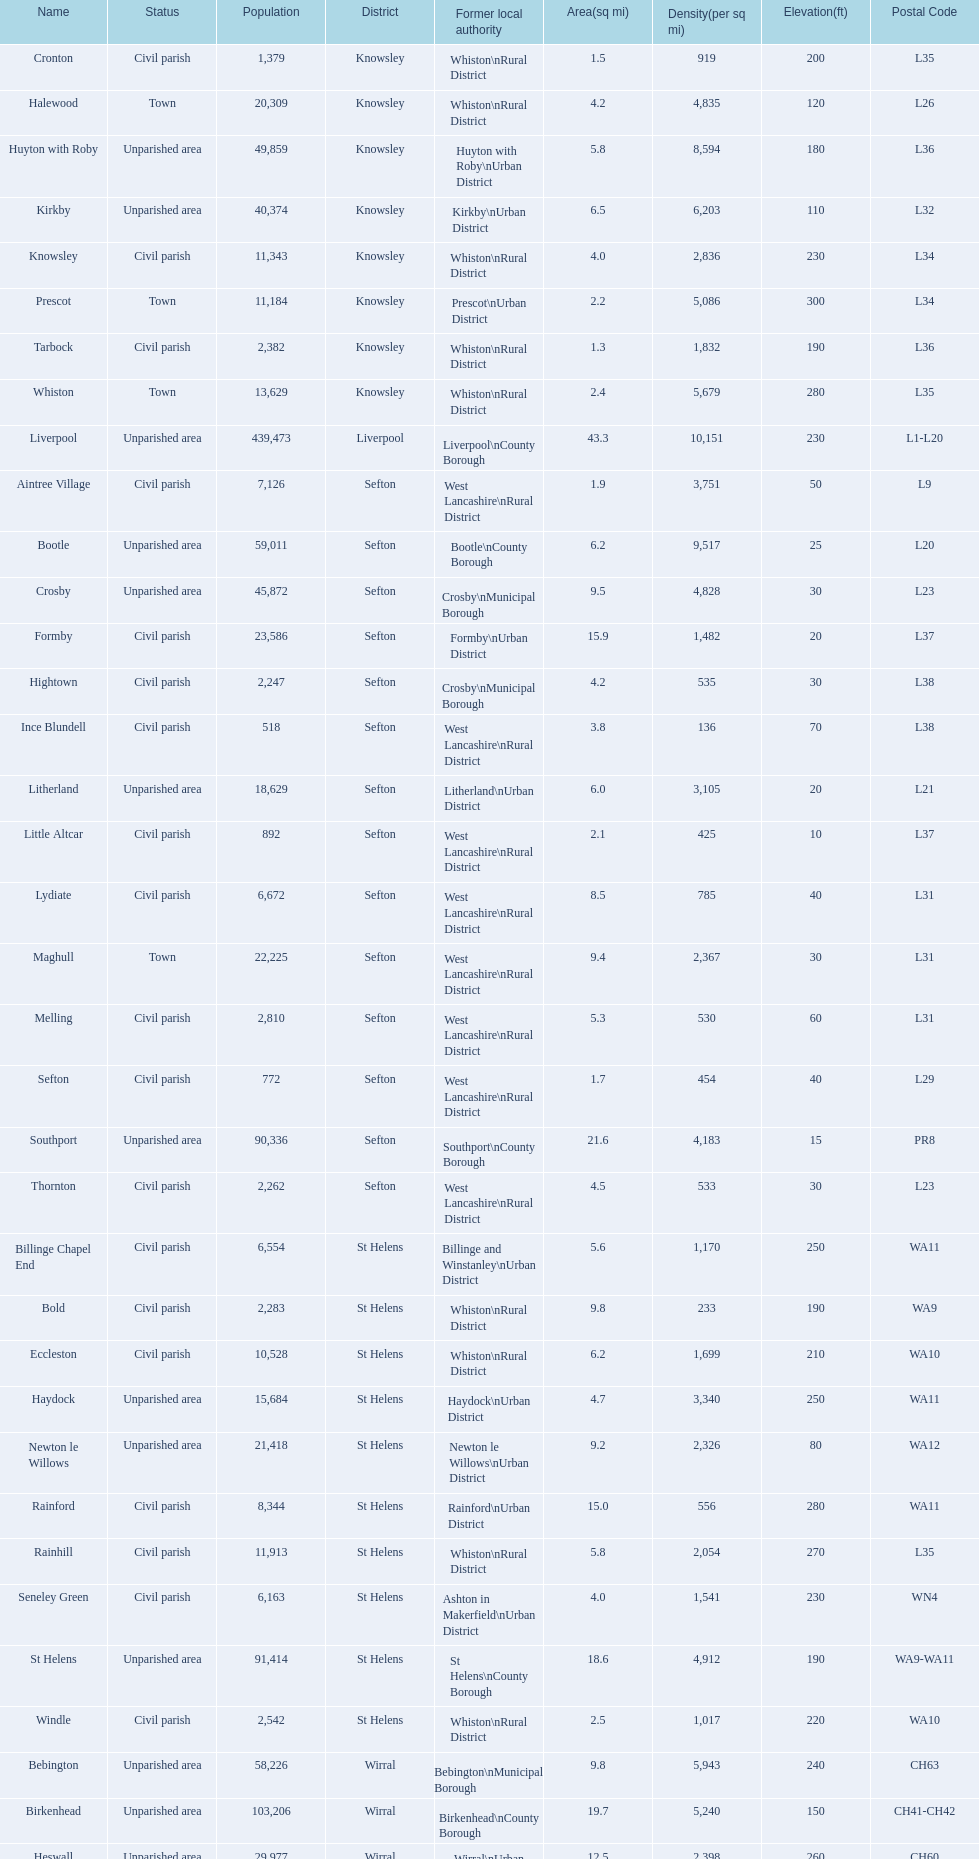Give me the full table as a dictionary. {'header': ['Name', 'Status', 'Population', 'District', 'Former local authority', 'Area(sq mi)', 'Density(per sq mi)', 'Elevation(ft)', 'Postal Code'], 'rows': [['Cronton', 'Civil parish', '1,379', 'Knowsley', 'Whiston\\nRural District', '1.5', '919', '200', 'L35'], ['Halewood', 'Town', '20,309', 'Knowsley', 'Whiston\\nRural District', '4.2', '4,835', '120', 'L26'], ['Huyton with Roby', 'Unparished area', '49,859', 'Knowsley', 'Huyton with Roby\\nUrban District', '5.8', '8,594', '180', 'L36'], ['Kirkby', 'Unparished area', '40,374', 'Knowsley', 'Kirkby\\nUrban District', '6.5', '6,203', '110', 'L32'], ['Knowsley', 'Civil parish', '11,343', 'Knowsley', 'Whiston\\nRural District', '4.0', '2,836', '230', 'L34'], ['Prescot', 'Town', '11,184', 'Knowsley', 'Prescot\\nUrban District', '2.2', '5,086', '300', 'L34'], ['Tarbock', 'Civil parish', '2,382', 'Knowsley', 'Whiston\\nRural District', '1.3', '1,832', '190', 'L36'], ['Whiston', 'Town', '13,629', 'Knowsley', 'Whiston\\nRural District', '2.4', '5,679', '280', 'L35'], ['Liverpool', 'Unparished area', '439,473', 'Liverpool', 'Liverpool\\nCounty Borough', '43.3', '10,151', '230', 'L1-L20'], ['Aintree Village', 'Civil parish', '7,126', 'Sefton', 'West Lancashire\\nRural District', '1.9', '3,751', '50', 'L9'], ['Bootle', 'Unparished area', '59,011', 'Sefton', 'Bootle\\nCounty Borough', '6.2', '9,517', '25', 'L20'], ['Crosby', 'Unparished area', '45,872', 'Sefton', 'Crosby\\nMunicipal Borough', '9.5', '4,828', '30', 'L23'], ['Formby', 'Civil parish', '23,586', 'Sefton', 'Formby\\nUrban District', '15.9', '1,482', '20', 'L37'], ['Hightown', 'Civil parish', '2,247', 'Sefton', 'Crosby\\nMunicipal Borough', '4.2', '535', '30', 'L38'], ['Ince Blundell', 'Civil parish', '518', 'Sefton', 'West Lancashire\\nRural District', '3.8', '136', '70', 'L38'], ['Litherland', 'Unparished area', '18,629', 'Sefton', 'Litherland\\nUrban District', '6.0', '3,105', '20', 'L21'], ['Little Altcar', 'Civil parish', '892', 'Sefton', 'West Lancashire\\nRural District', '2.1', '425', '10', 'L37'], ['Lydiate', 'Civil parish', '6,672', 'Sefton', 'West Lancashire\\nRural District', '8.5', '785', '40', 'L31'], ['Maghull', 'Town', '22,225', 'Sefton', 'West Lancashire\\nRural District', '9.4', '2,367', '30', 'L31'], ['Melling', 'Civil parish', '2,810', 'Sefton', 'West Lancashire\\nRural District', '5.3', '530', '60', 'L31'], ['Sefton', 'Civil parish', '772', 'Sefton', 'West Lancashire\\nRural District', '1.7', '454', '40', 'L29'], ['Southport', 'Unparished area', '90,336', 'Sefton', 'Southport\\nCounty Borough', '21.6', '4,183', '15', 'PR8'], ['Thornton', 'Civil parish', '2,262', 'Sefton', 'West Lancashire\\nRural District', '4.5', '533', '30', 'L23'], ['Billinge Chapel End', 'Civil parish', '6,554', 'St Helens', 'Billinge and Winstanley\\nUrban District', '5.6', '1,170', '250', 'WA11'], ['Bold', 'Civil parish', '2,283', 'St Helens', 'Whiston\\nRural District', '9.8', '233', '190', 'WA9'], ['Eccleston', 'Civil parish', '10,528', 'St Helens', 'Whiston\\nRural District', '6.2', '1,699', '210', 'WA10'], ['Haydock', 'Unparished area', '15,684', 'St Helens', 'Haydock\\nUrban District', '4.7', '3,340', '250', 'WA11'], ['Newton le Willows', 'Unparished area', '21,418', 'St Helens', 'Newton le Willows\\nUrban District', '9.2', '2,326', '80', 'WA12'], ['Rainford', 'Civil parish', '8,344', 'St Helens', 'Rainford\\nUrban District', '15.0', '556', '280', 'WA11'], ['Rainhill', 'Civil parish', '11,913', 'St Helens', 'Whiston\\nRural District', '5.8', '2,054', '270', 'L35'], ['Seneley Green', 'Civil parish', '6,163', 'St Helens', 'Ashton in Makerfield\\nUrban District', '4.0', '1,541', '230', 'WN4'], ['St Helens', 'Unparished area', '91,414', 'St Helens', 'St Helens\\nCounty Borough', '18.6', '4,912', '190', 'WA9-WA11'], ['Windle', 'Civil parish', '2,542', 'St Helens', 'Whiston\\nRural District', '2.5', '1,017', '220', 'WA10'], ['Bebington', 'Unparished area', '58,226', 'Wirral', 'Bebington\\nMunicipal Borough', '9.8', '5,943', '240', 'CH63'], ['Birkenhead', 'Unparished area', '103,206', 'Wirral', 'Birkenhead\\nCounty Borough', '19.7', '5,240', '150', 'CH41-CH42'], ['Heswall', 'Unparished area', '29,977', 'Wirral', 'Wirral\\nUrban District', '12.5', '2,398', '260', 'CH60'], ['Hoylake', 'Unparished area', '35,655', 'Wirral', 'Hoylake\\nUrban District', '9.6', '3,713', '30', 'CH47'], ['Wallasey', 'Unparished area', '84,348', 'Wirral', 'Wallasey\\nCounty Borough', '17.3', '4,873', '90', 'CH44-CH45']]} Which area has the least number of residents? Ince Blundell. 